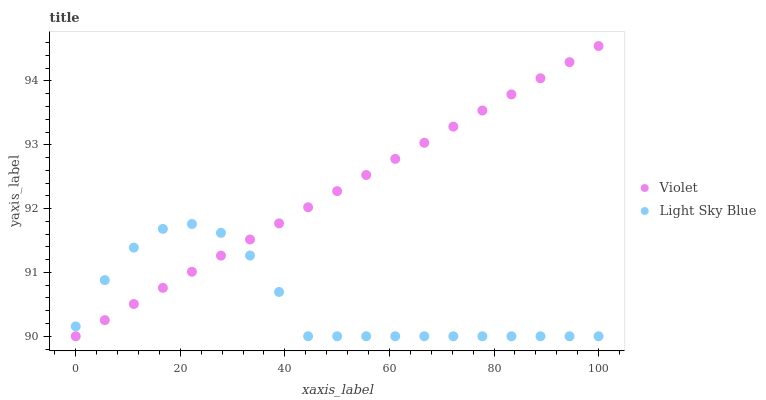Does Light Sky Blue have the minimum area under the curve?
Answer yes or no. Yes. Does Violet have the maximum area under the curve?
Answer yes or no. Yes. Does Violet have the minimum area under the curve?
Answer yes or no. No. Is Violet the smoothest?
Answer yes or no. Yes. Is Light Sky Blue the roughest?
Answer yes or no. Yes. Is Violet the roughest?
Answer yes or no. No. Does Light Sky Blue have the lowest value?
Answer yes or no. Yes. Does Violet have the highest value?
Answer yes or no. Yes. Does Light Sky Blue intersect Violet?
Answer yes or no. Yes. Is Light Sky Blue less than Violet?
Answer yes or no. No. Is Light Sky Blue greater than Violet?
Answer yes or no. No. 